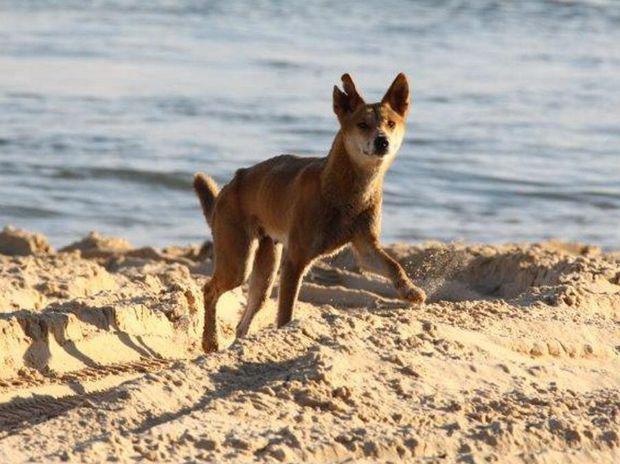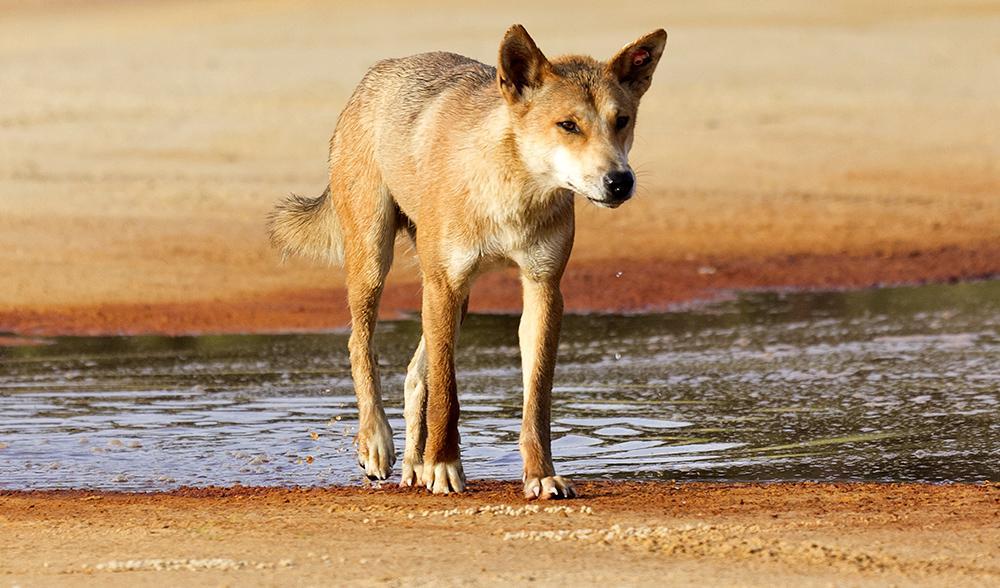The first image is the image on the left, the second image is the image on the right. Given the left and right images, does the statement "At least one dog is in water, surrounded by water." hold true? Answer yes or no. No. 